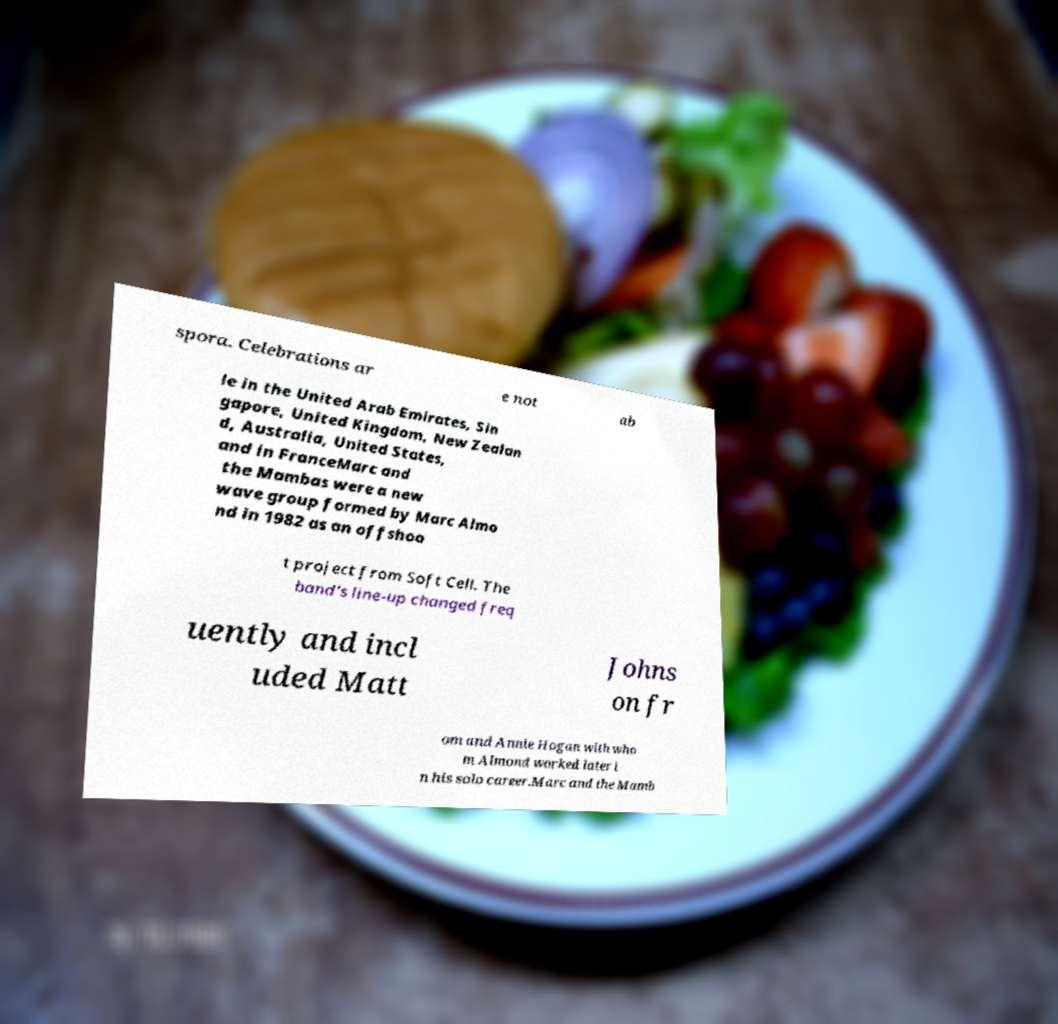Can you read and provide the text displayed in the image?This photo seems to have some interesting text. Can you extract and type it out for me? spora. Celebrations ar e not ab le in the United Arab Emirates, Sin gapore, United Kingdom, New Zealan d, Australia, United States, and in FranceMarc and the Mambas were a new wave group formed by Marc Almo nd in 1982 as an offshoo t project from Soft Cell. The band's line-up changed freq uently and incl uded Matt Johns on fr om and Annie Hogan with who m Almond worked later i n his solo career.Marc and the Mamb 